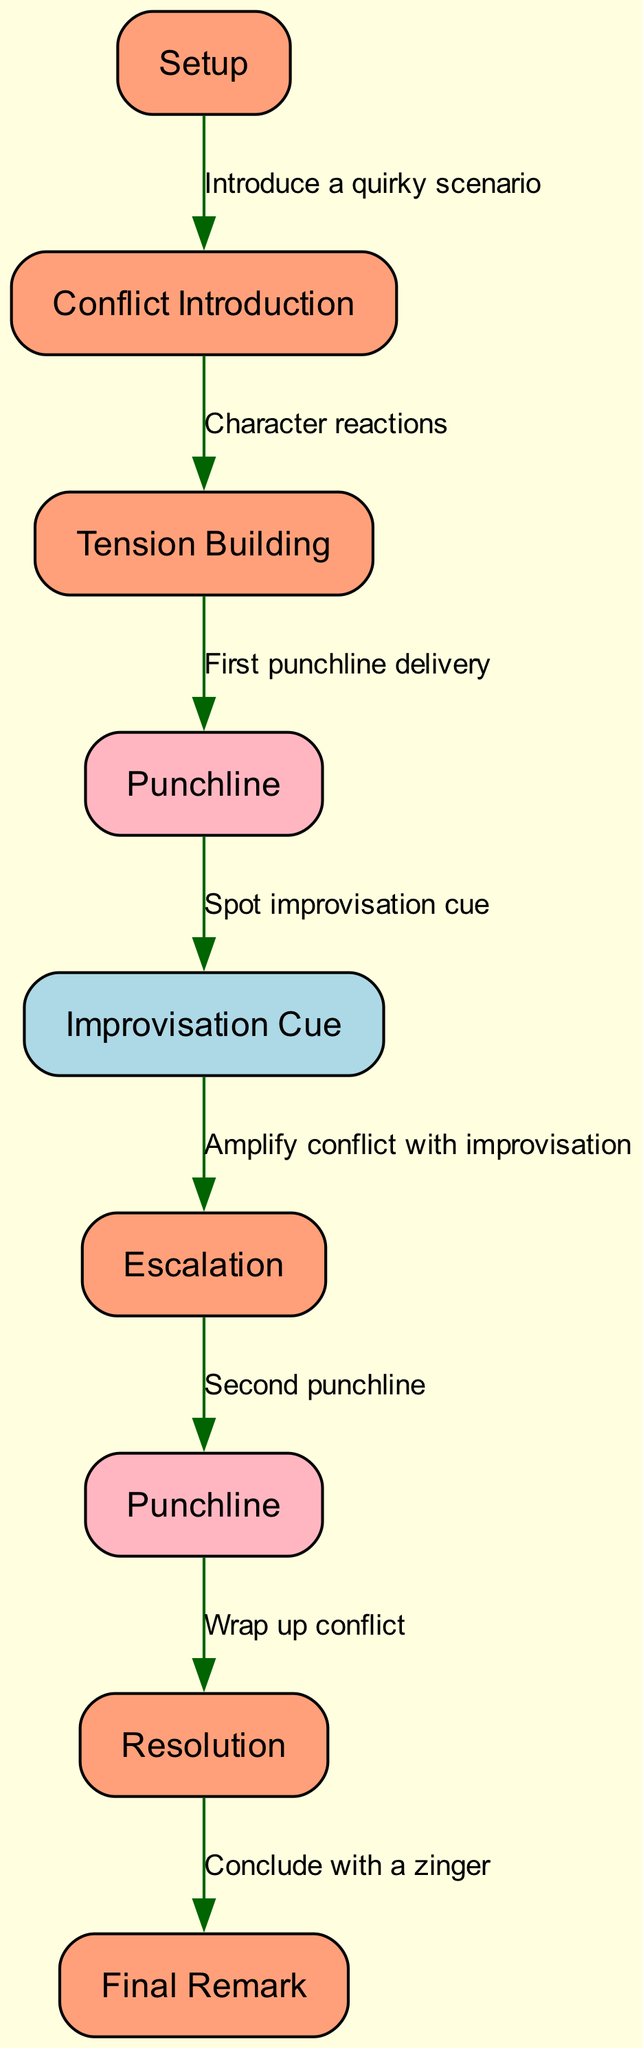What is the first node in the diagram? The first node in the diagram is "Setup." It is labeled at the top of the diagram and represents the starting point for the comedic skit.
Answer: Setup How many punchlines are present in the diagram? There are two punchlines shown in the diagram, labeled as "Punchline" and "Punchline." This can be counted by identifying the nodes that contain the word "Punchline."
Answer: 2 What is the label of the first punchline? The label of the first punchline is "Punchline." It directly follows the "Tension Building" node in the sequence of the skit.
Answer: Punchline What is the relationship between "BuildUp" and "Punchline1"? The relationship is defined by the edge labeled "First punchline delivery," indicating that the action taken at the "BuildUp" node leads to the first punchline being delivered.
Answer: First punchline delivery What comes after "Improvisation Cue"? The next node after "Improvisation Cue" is "Escalation," showing that after spotting the improvisation cue, the conflict is amplified.
Answer: Escalation What type of cue is indicated right after the first punchline? The cue indicated right after the first punchline is an "Improvisation Cue," highlighting a point where improvised humor can be inserted following the punchline.
Answer: Improvisation Cue In which sequence does the second punchline occur? The second punchline occurs after "Escalation," as indicated by the flow of the diagram leading from the escalation of conflict to delivering the second punchline.
Answer: After Escalation What is the final remark in the skit flow? The final remark in the skit flow is labeled "Final Remark," which comes after the resolution of the comedic conflict, serving as a concluding statement.
Answer: Final Remark What kind of scenario is introduced at the beginning? A "quirky scenario" is introduced at the beginning during the "Setup," setting the tone for the comedic elements to unfold.
Answer: Quirky scenario 